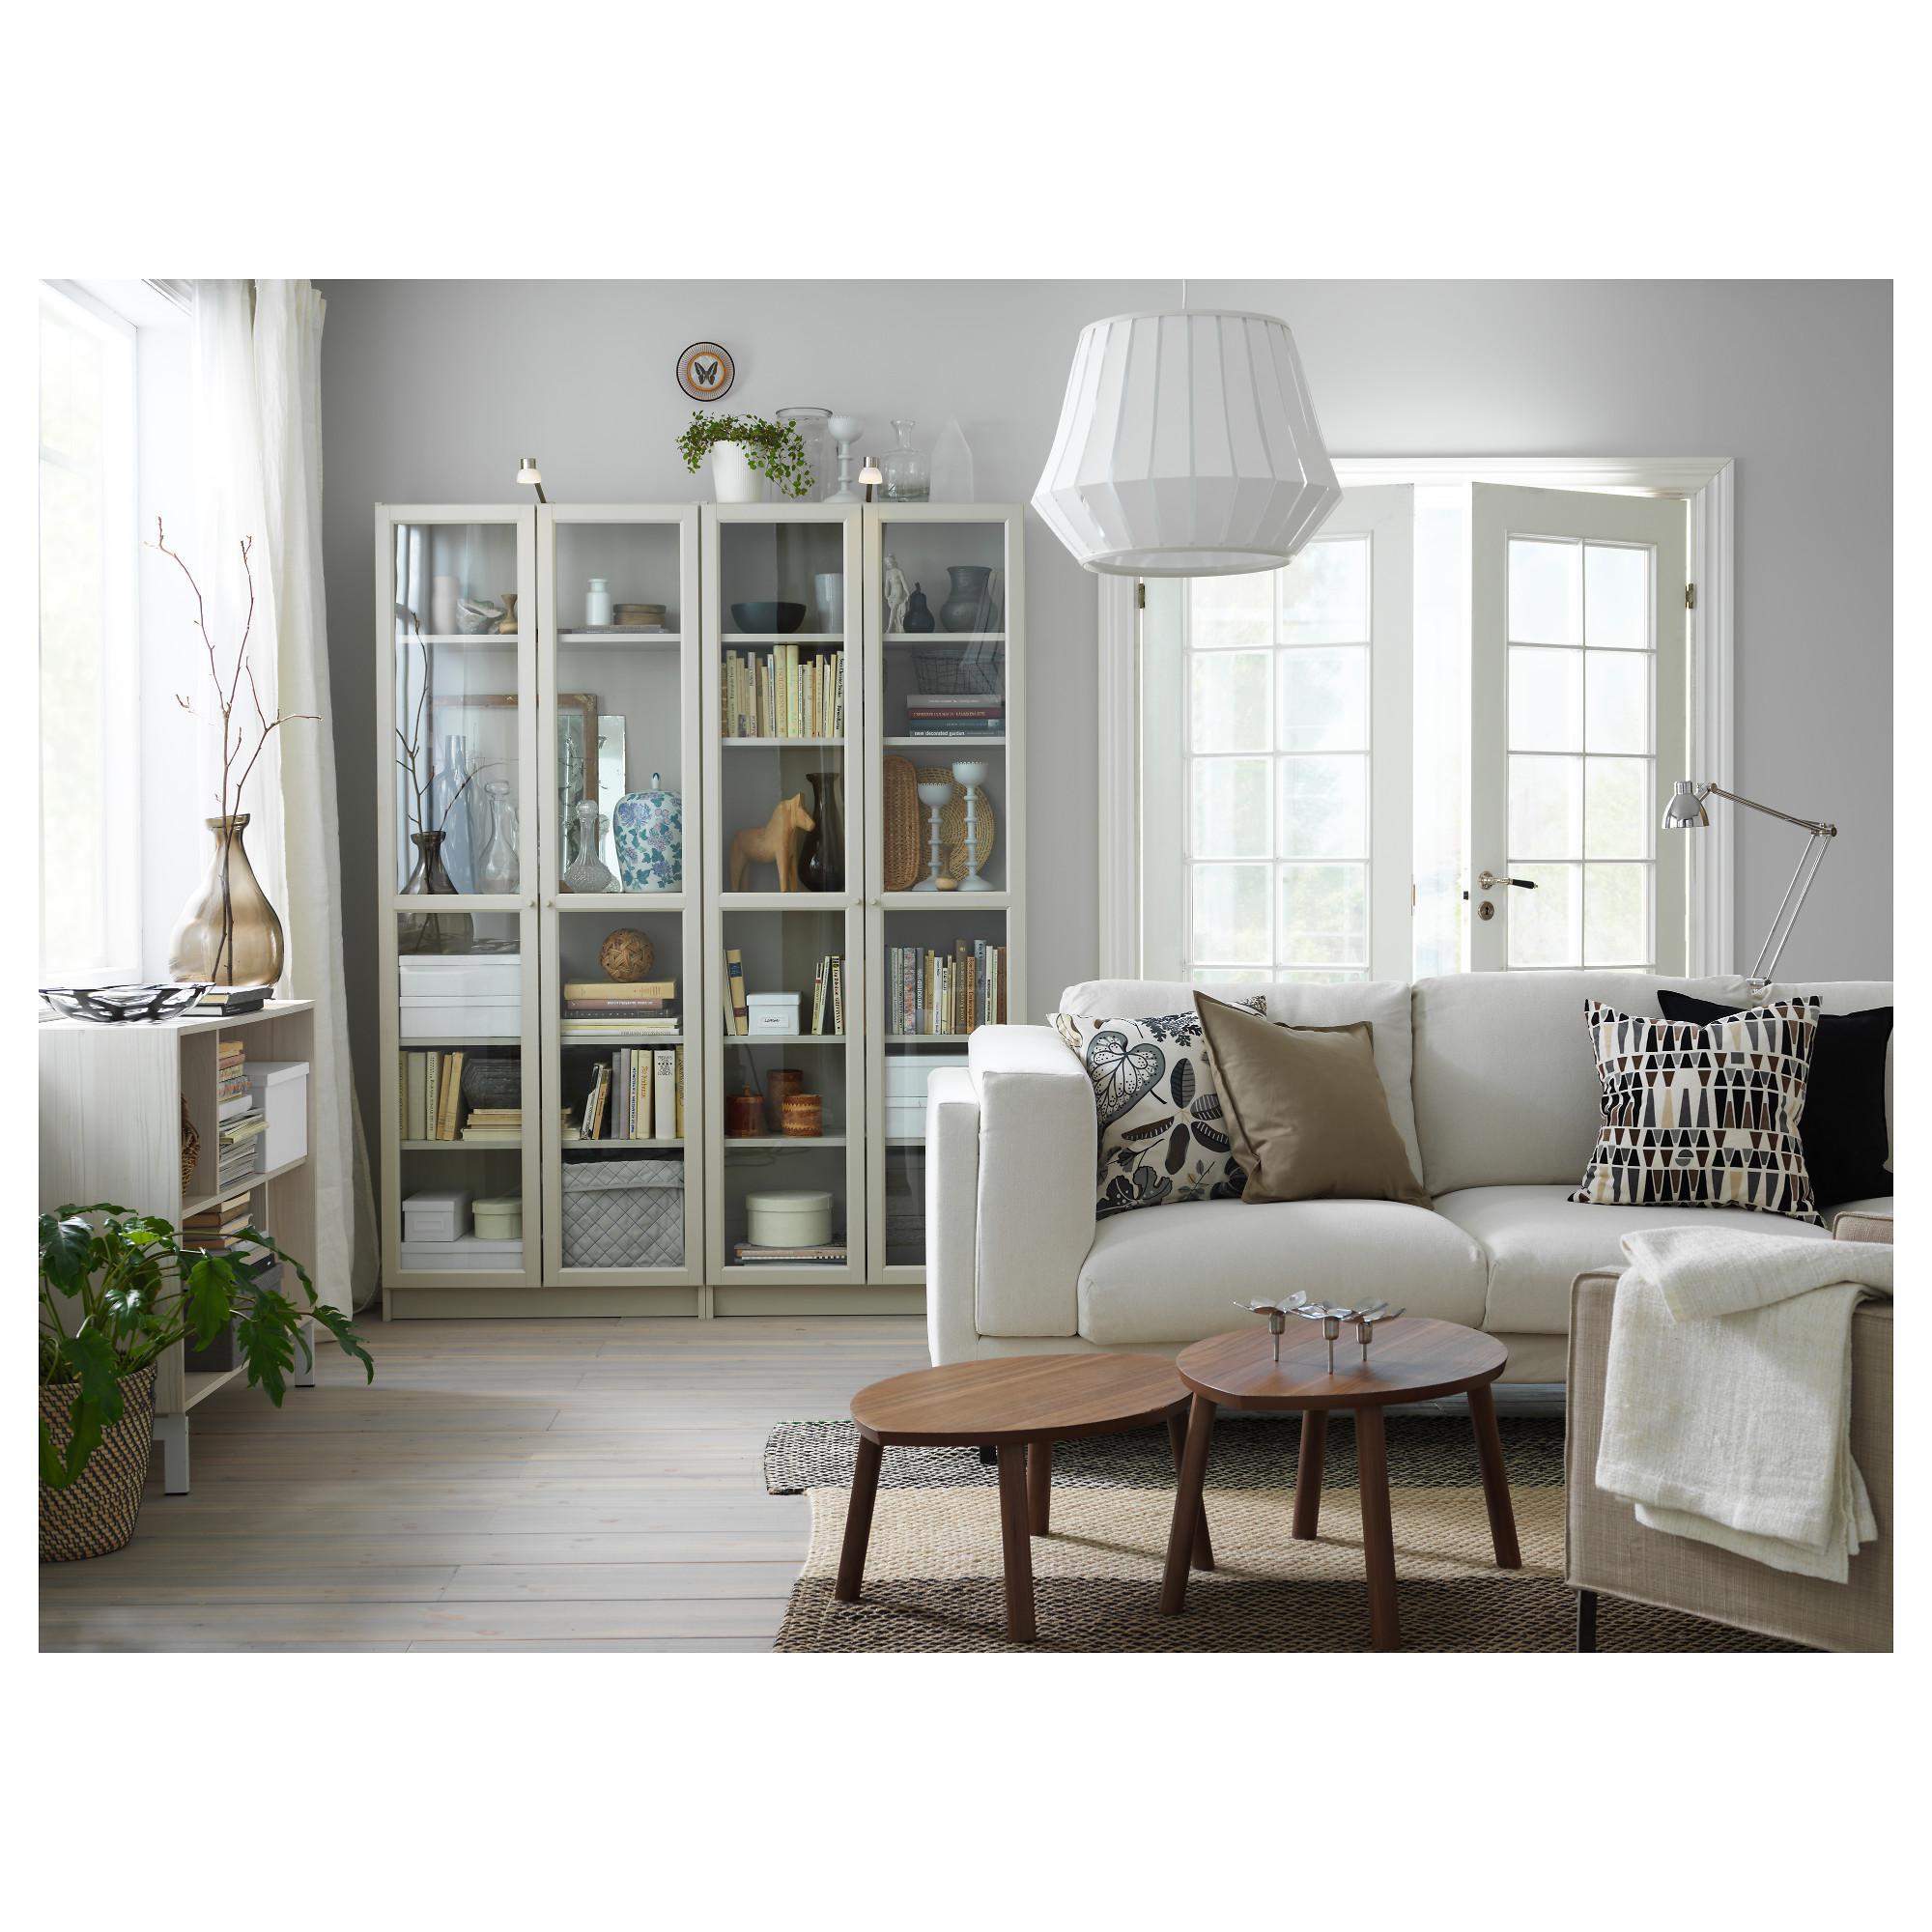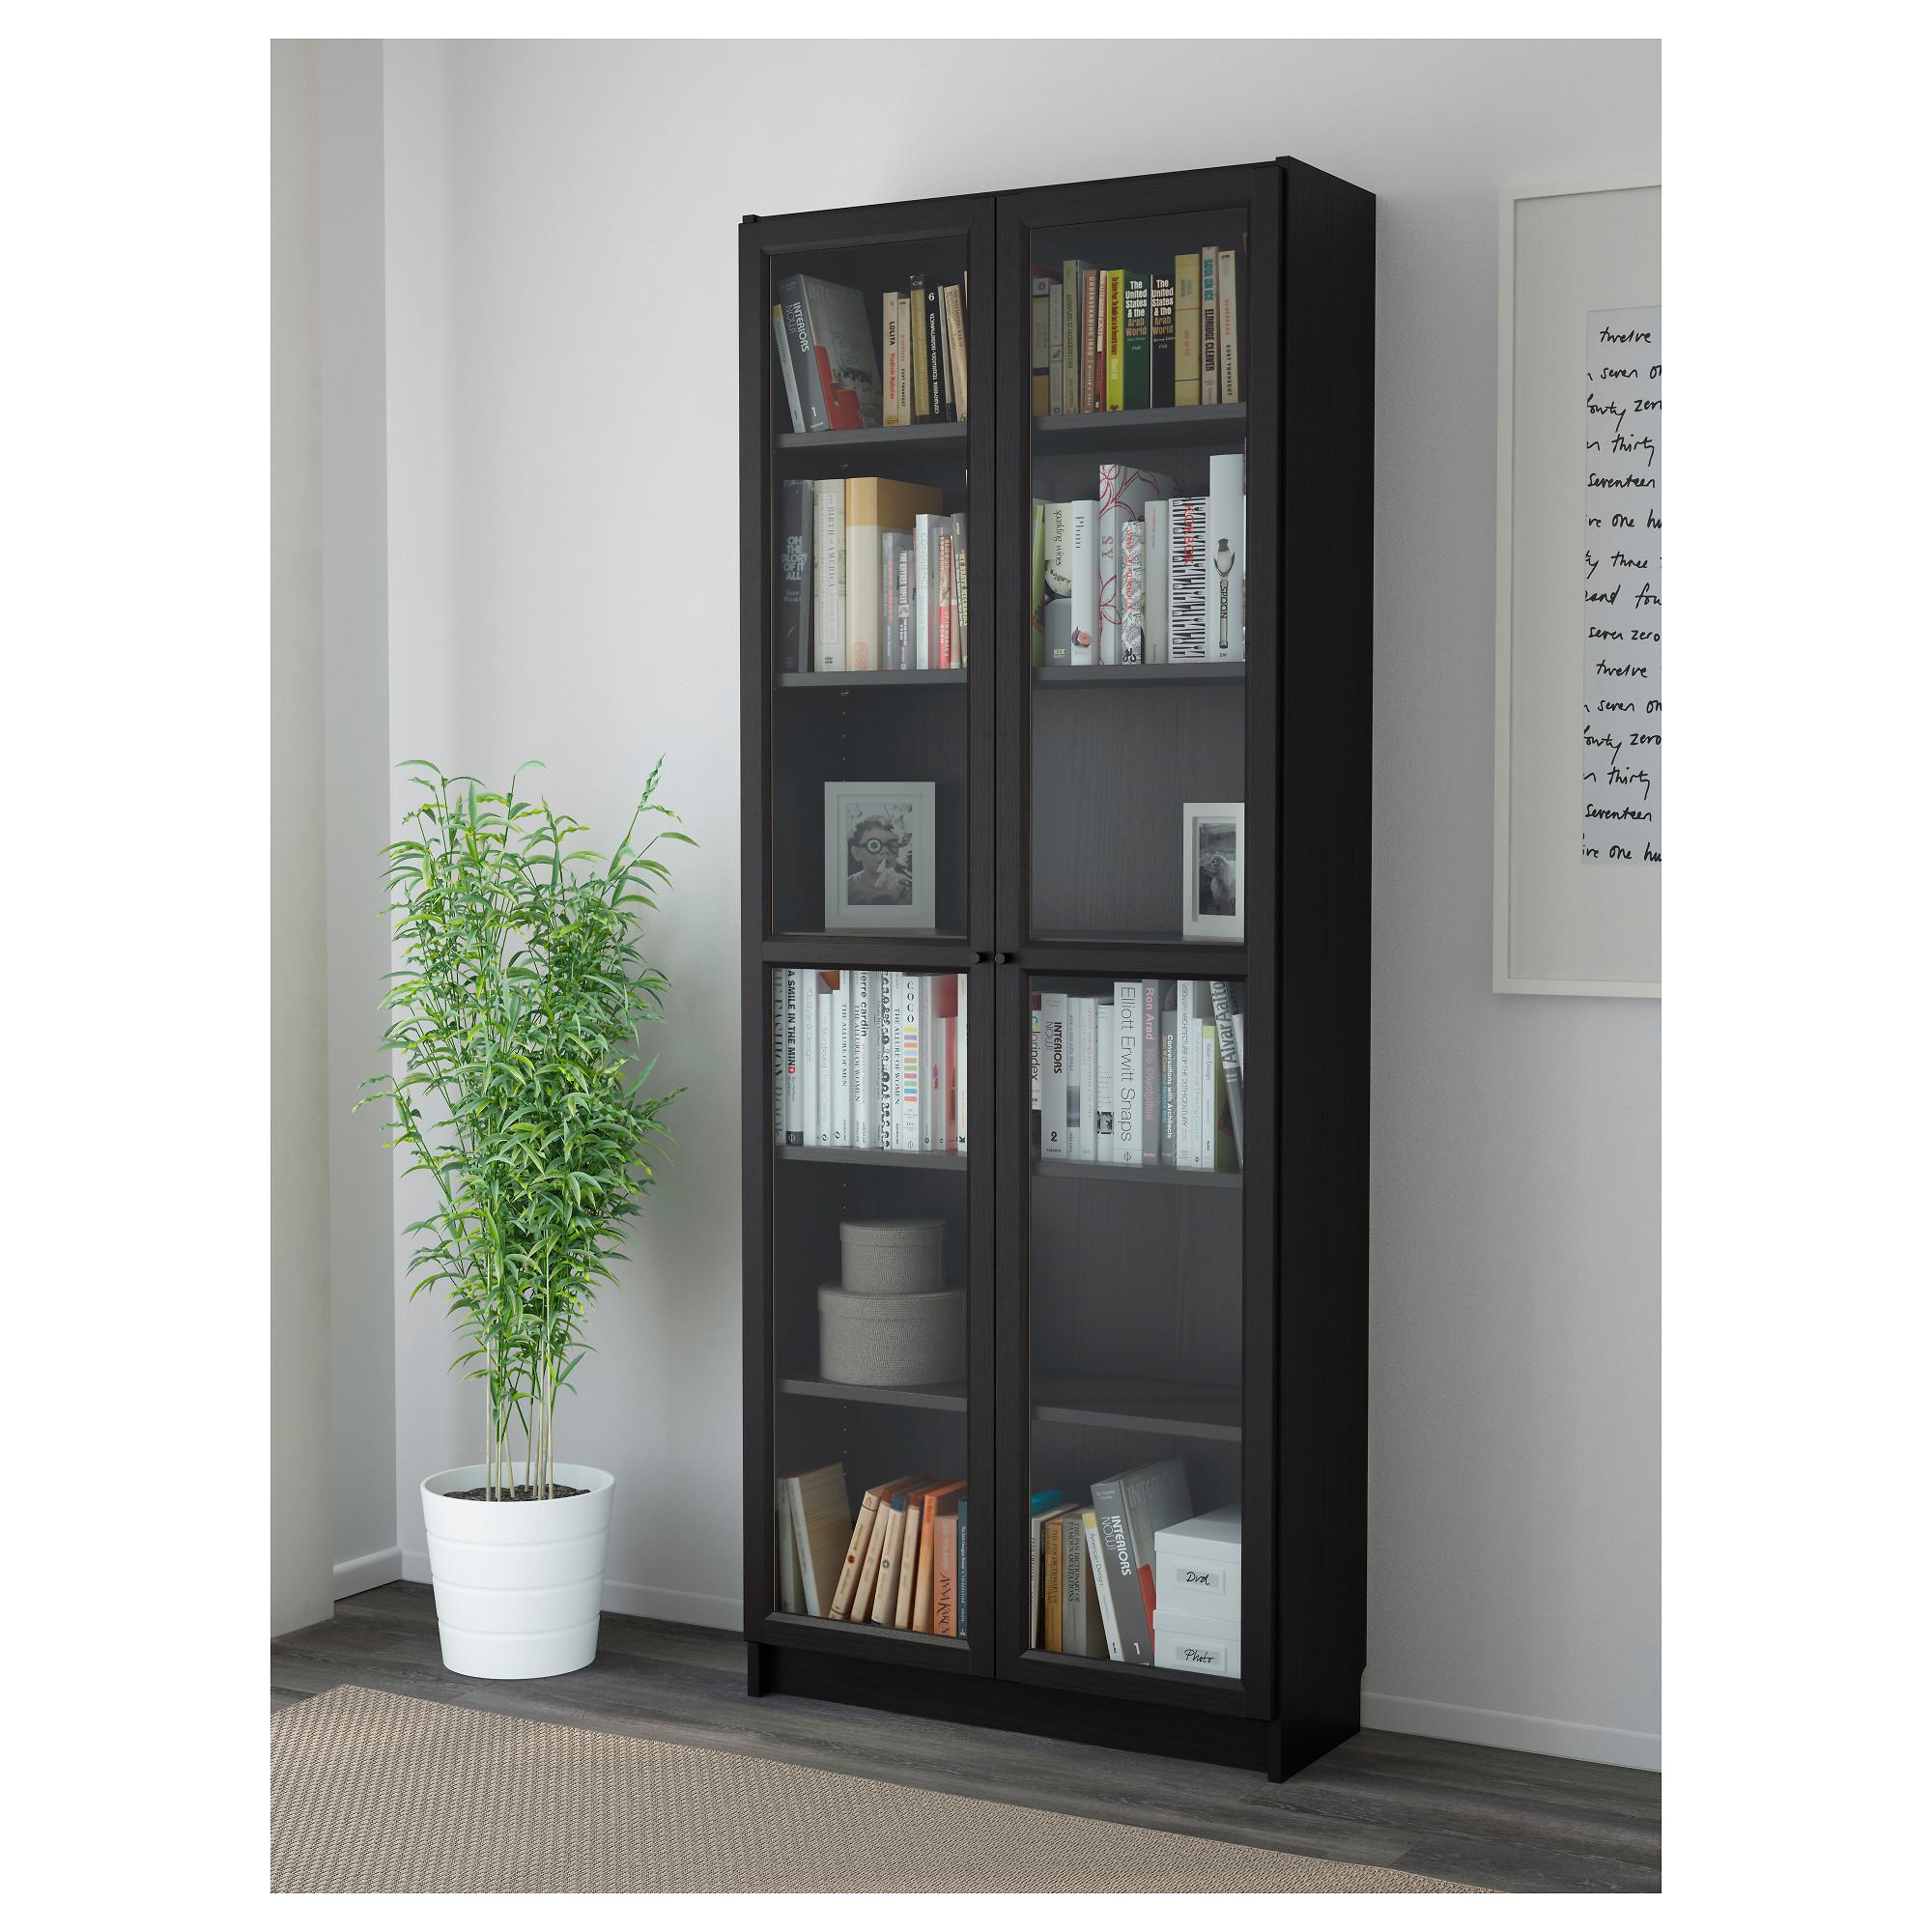The first image is the image on the left, the second image is the image on the right. For the images displayed, is the sentence "A single white lamp hangs down from the ceiling in one of the images." factually correct? Answer yes or no. Yes. The first image is the image on the left, the second image is the image on the right. Analyze the images presented: Is the assertion "One image shows a green plant in a white vase standing on the floor to the left of an upright set of shelves with closed, glass-front double doors." valid? Answer yes or no. Yes. 